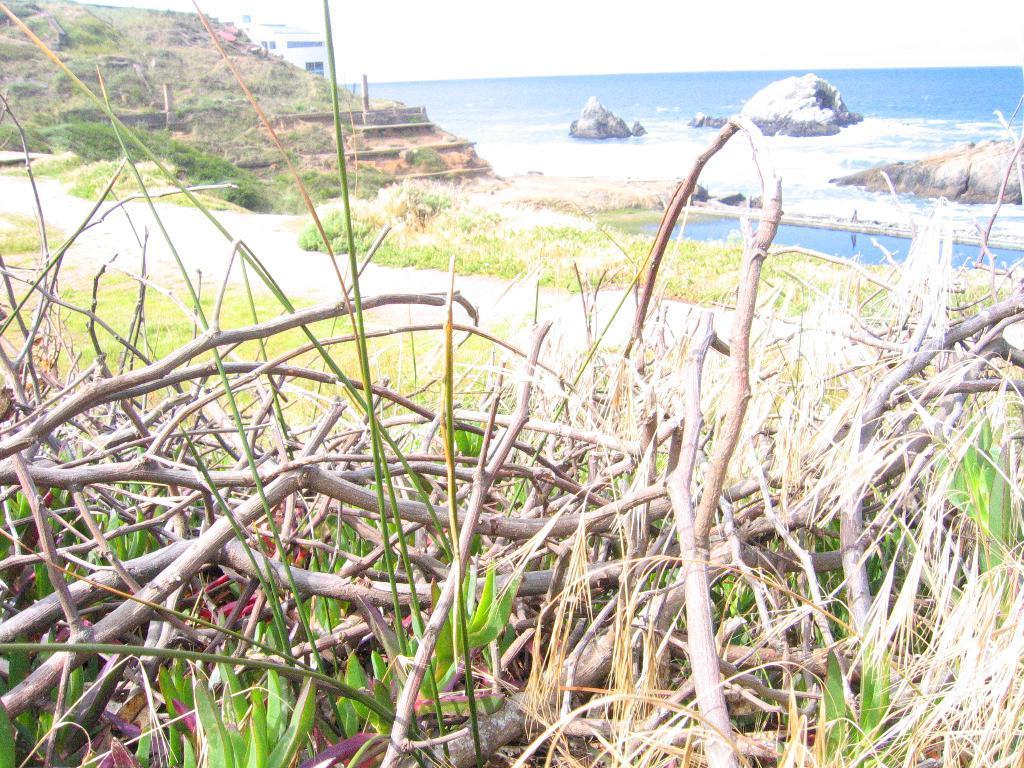In one or two sentences, can you explain what this image depicts? In this image, we can see some woods and there is grass, plants and there is water, we can see the rocks in the water. 